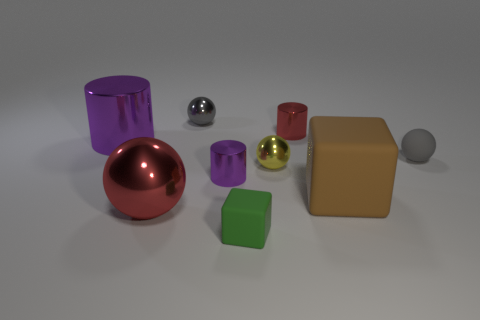What number of things are either purple objects to the left of the red shiny ball or small objects that are in front of the large purple cylinder?
Give a very brief answer. 5. What is the shape of the yellow shiny object that is the same size as the green thing?
Provide a short and direct response. Sphere. Are there any other rubber things of the same shape as the brown object?
Make the answer very short. Yes. Is the number of rubber blocks less than the number of big rubber objects?
Ensure brevity in your answer.  No. Is the size of the red thing that is to the left of the tiny gray metallic sphere the same as the matte cube on the right side of the small green cube?
Ensure brevity in your answer.  Yes. What number of objects are either big cylinders or small green objects?
Provide a short and direct response. 2. How big is the cube that is right of the red shiny cylinder?
Give a very brief answer. Large. There is a red shiny thing to the left of the block that is in front of the large rubber block; how many small metal spheres are on the left side of it?
Offer a terse response. 0. How many purple metallic things are behind the yellow thing and in front of the tiny yellow ball?
Ensure brevity in your answer.  0. The tiny shiny object behind the small red cylinder has what shape?
Give a very brief answer. Sphere. 